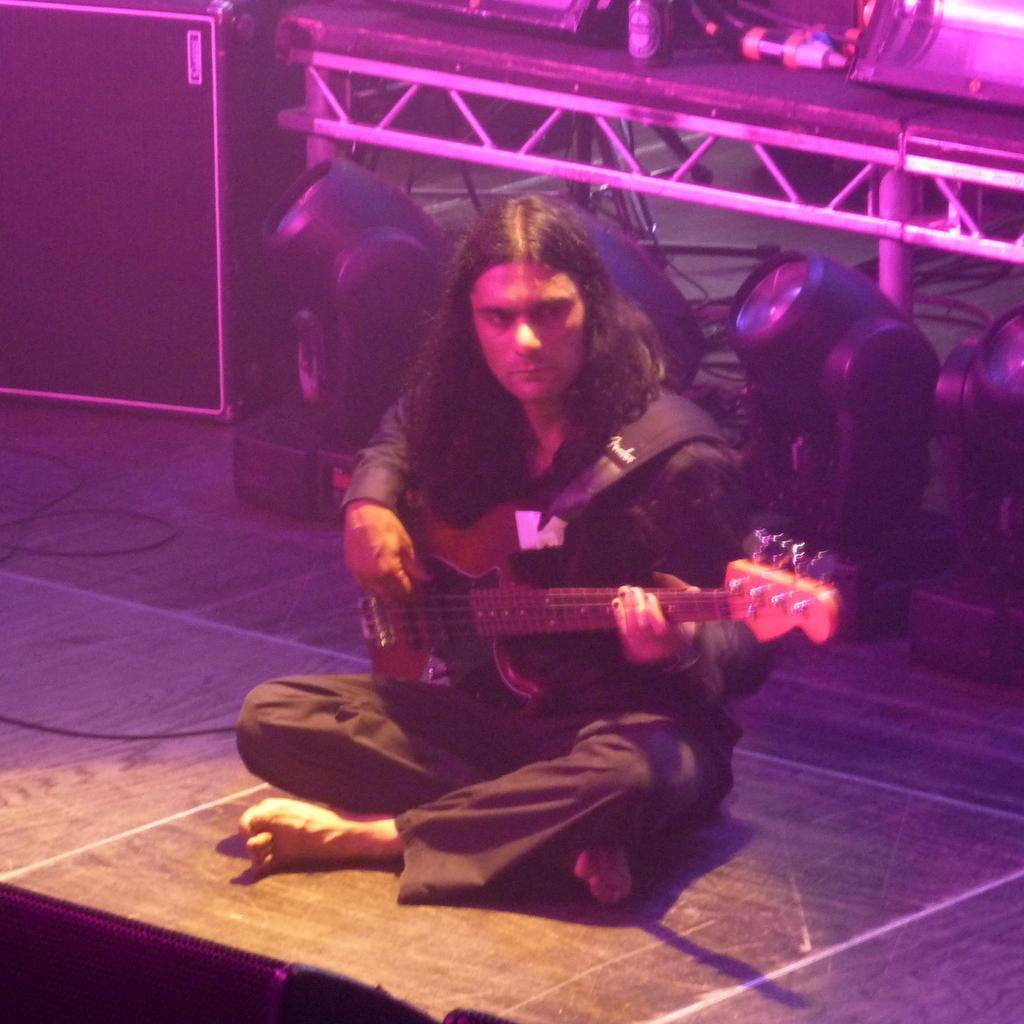Please provide a concise description of this image. There is a man with long hair sitting on the stage and holding guitar. In the background there are poles,lights and a box. 